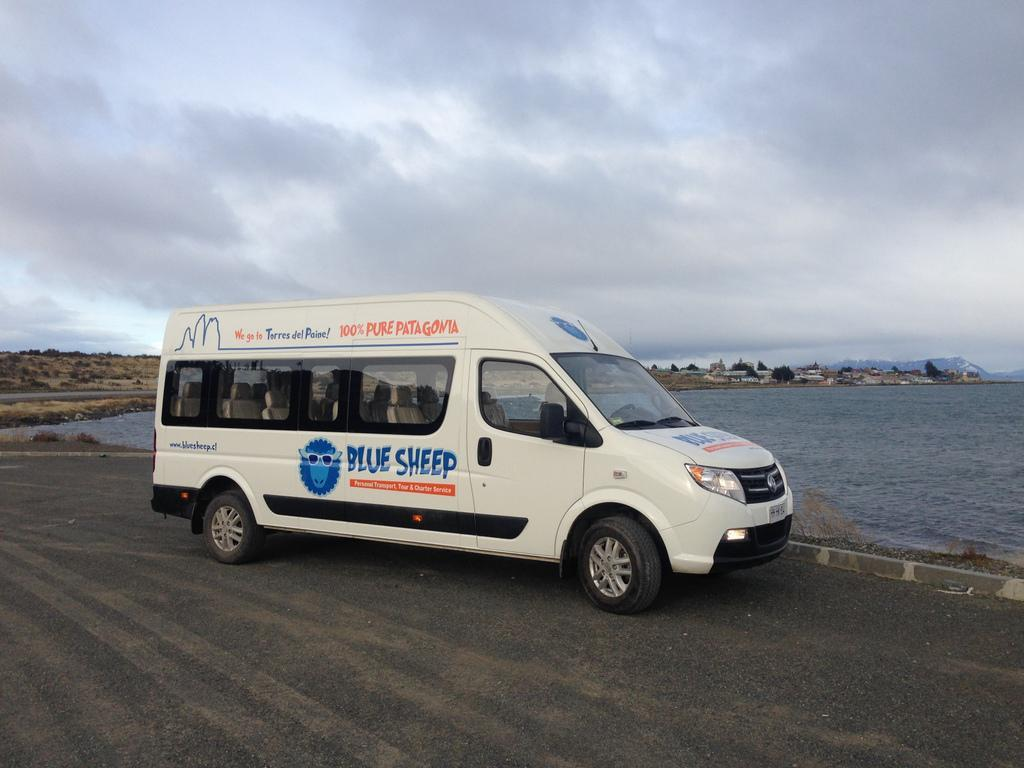<image>
Render a clear and concise summary of the photo. A white tour van from Blue Sheep is near a body of water. 